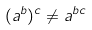Convert formula to latex. <formula><loc_0><loc_0><loc_500><loc_500>( a ^ { b } ) ^ { c } \ne a ^ { b c }</formula> 